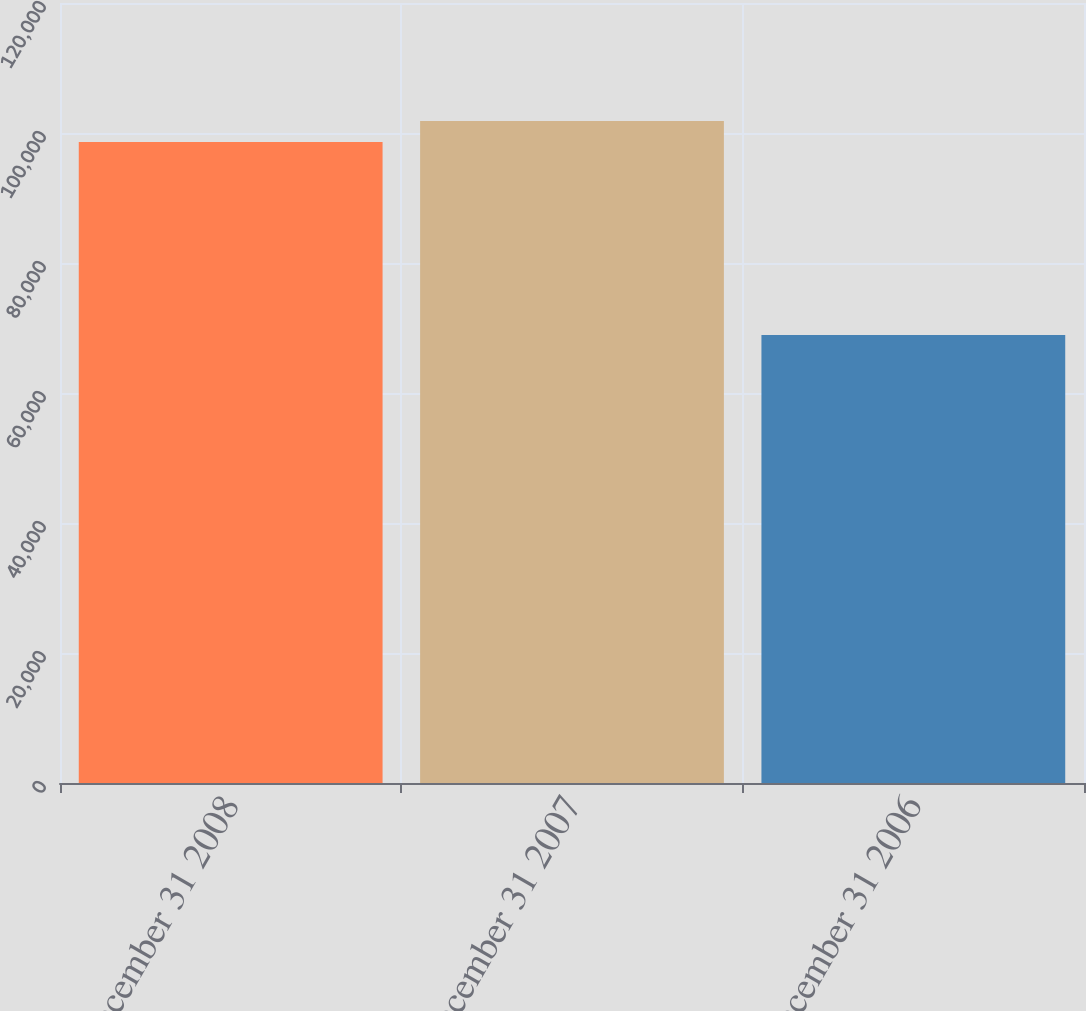<chart> <loc_0><loc_0><loc_500><loc_500><bar_chart><fcel>December 31 2008<fcel>December 31 2007<fcel>December 31 2006<nl><fcel>98629<fcel>101864<fcel>68911<nl></chart> 